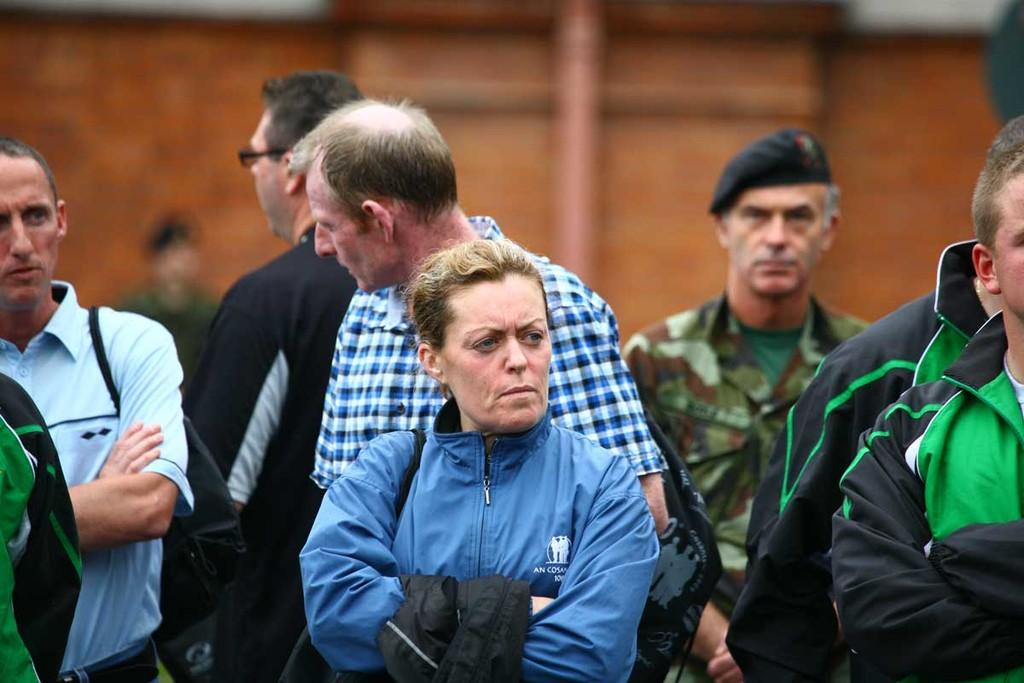How many people are in the image? There are many persons in the image. What is the position of the persons in the image? The persons are on the ground. What can be seen in the background of the image? There is a building in the background of the image. What direction is the sun shining from in the image? There is no mention of the sun in the image, so we cannot determine the direction it is shining from. 